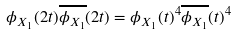Convert formula to latex. <formula><loc_0><loc_0><loc_500><loc_500>\phi _ { X _ { 1 } } ( 2 t ) \overline { \phi _ { X _ { 1 } } } ( 2 t ) = \phi _ { X _ { 1 } } ( t ) ^ { 4 } \overline { \phi _ { X _ { 1 } } } ( t ) ^ { 4 }</formula> 